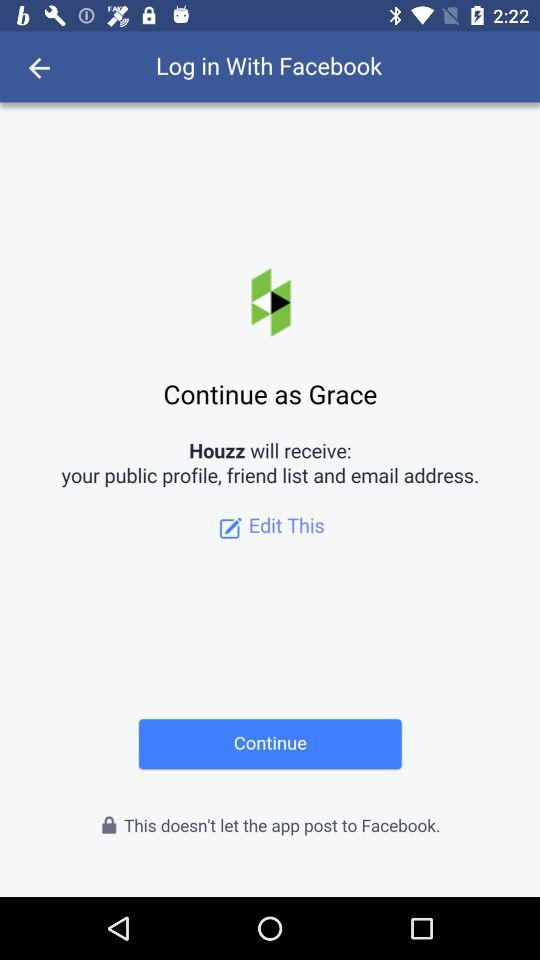What is the name of the user? The name of the user is Grace. 